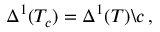Convert formula to latex. <formula><loc_0><loc_0><loc_500><loc_500>\Delta ^ { 1 } ( T _ { c } ) = \Delta ^ { 1 } ( T ) \ c \, ,</formula> 